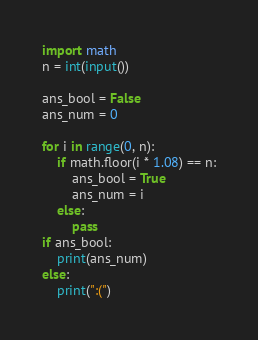Convert code to text. <code><loc_0><loc_0><loc_500><loc_500><_Python_>import math
n = int(input())

ans_bool = False
ans_num = 0

for i in range(0, n):
    if math.floor(i * 1.08) == n:
        ans_bool = True
        ans_num = i
    else:
        pass
if ans_bool:
    print(ans_num)
else:
    print(":(")
</code> 